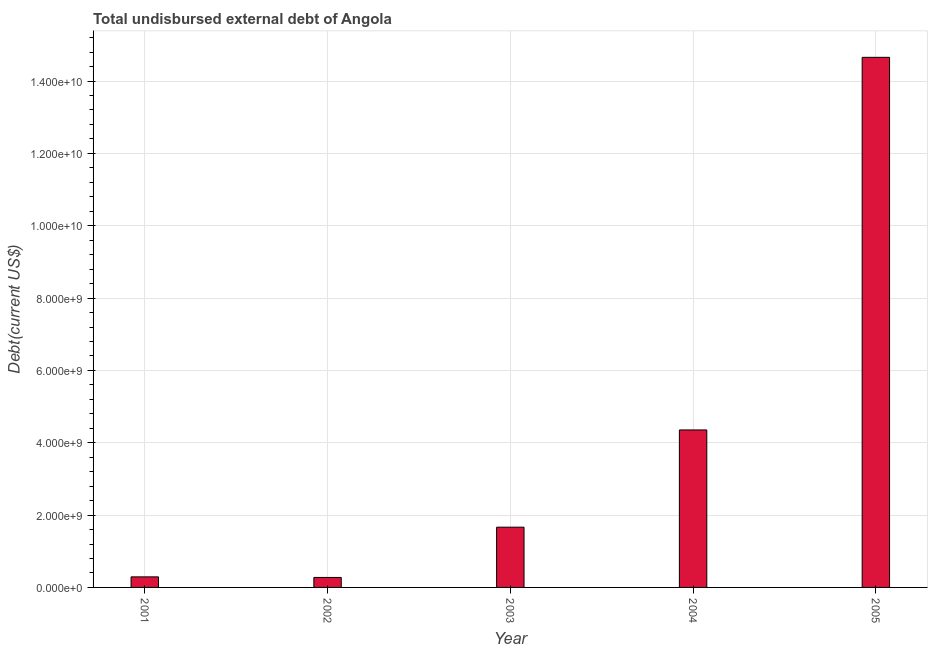Does the graph contain any zero values?
Make the answer very short. No. Does the graph contain grids?
Provide a succinct answer. Yes. What is the title of the graph?
Make the answer very short. Total undisbursed external debt of Angola. What is the label or title of the Y-axis?
Your answer should be very brief. Debt(current US$). What is the total debt in 2003?
Provide a short and direct response. 1.67e+09. Across all years, what is the maximum total debt?
Make the answer very short. 1.47e+1. Across all years, what is the minimum total debt?
Offer a very short reply. 2.76e+08. What is the sum of the total debt?
Your answer should be compact. 2.12e+1. What is the difference between the total debt in 2001 and 2005?
Keep it short and to the point. -1.44e+1. What is the average total debt per year?
Your answer should be compact. 4.25e+09. What is the median total debt?
Ensure brevity in your answer.  1.67e+09. In how many years, is the total debt greater than 6400000000 US$?
Your answer should be very brief. 1. Do a majority of the years between 2001 and 2005 (inclusive) have total debt greater than 1600000000 US$?
Your answer should be compact. Yes. What is the ratio of the total debt in 2004 to that in 2005?
Offer a very short reply. 0.3. Is the total debt in 2001 less than that in 2004?
Your answer should be very brief. Yes. What is the difference between the highest and the second highest total debt?
Your response must be concise. 1.03e+1. What is the difference between the highest and the lowest total debt?
Offer a very short reply. 1.44e+1. How many years are there in the graph?
Keep it short and to the point. 5. What is the Debt(current US$) of 2001?
Keep it short and to the point. 2.92e+08. What is the Debt(current US$) of 2002?
Offer a very short reply. 2.76e+08. What is the Debt(current US$) of 2003?
Offer a terse response. 1.67e+09. What is the Debt(current US$) in 2004?
Provide a short and direct response. 4.35e+09. What is the Debt(current US$) of 2005?
Provide a succinct answer. 1.47e+1. What is the difference between the Debt(current US$) in 2001 and 2002?
Your answer should be very brief. 1.60e+07. What is the difference between the Debt(current US$) in 2001 and 2003?
Offer a very short reply. -1.37e+09. What is the difference between the Debt(current US$) in 2001 and 2004?
Provide a succinct answer. -4.06e+09. What is the difference between the Debt(current US$) in 2001 and 2005?
Offer a terse response. -1.44e+1. What is the difference between the Debt(current US$) in 2002 and 2003?
Ensure brevity in your answer.  -1.39e+09. What is the difference between the Debt(current US$) in 2002 and 2004?
Offer a terse response. -4.08e+09. What is the difference between the Debt(current US$) in 2002 and 2005?
Give a very brief answer. -1.44e+1. What is the difference between the Debt(current US$) in 2003 and 2004?
Keep it short and to the point. -2.69e+09. What is the difference between the Debt(current US$) in 2003 and 2005?
Your answer should be compact. -1.30e+1. What is the difference between the Debt(current US$) in 2004 and 2005?
Offer a very short reply. -1.03e+1. What is the ratio of the Debt(current US$) in 2001 to that in 2002?
Offer a very short reply. 1.06. What is the ratio of the Debt(current US$) in 2001 to that in 2003?
Ensure brevity in your answer.  0.17. What is the ratio of the Debt(current US$) in 2001 to that in 2004?
Ensure brevity in your answer.  0.07. What is the ratio of the Debt(current US$) in 2002 to that in 2003?
Ensure brevity in your answer.  0.17. What is the ratio of the Debt(current US$) in 2002 to that in 2004?
Offer a very short reply. 0.06. What is the ratio of the Debt(current US$) in 2002 to that in 2005?
Ensure brevity in your answer.  0.02. What is the ratio of the Debt(current US$) in 2003 to that in 2004?
Offer a terse response. 0.38. What is the ratio of the Debt(current US$) in 2003 to that in 2005?
Give a very brief answer. 0.11. What is the ratio of the Debt(current US$) in 2004 to that in 2005?
Keep it short and to the point. 0.3. 